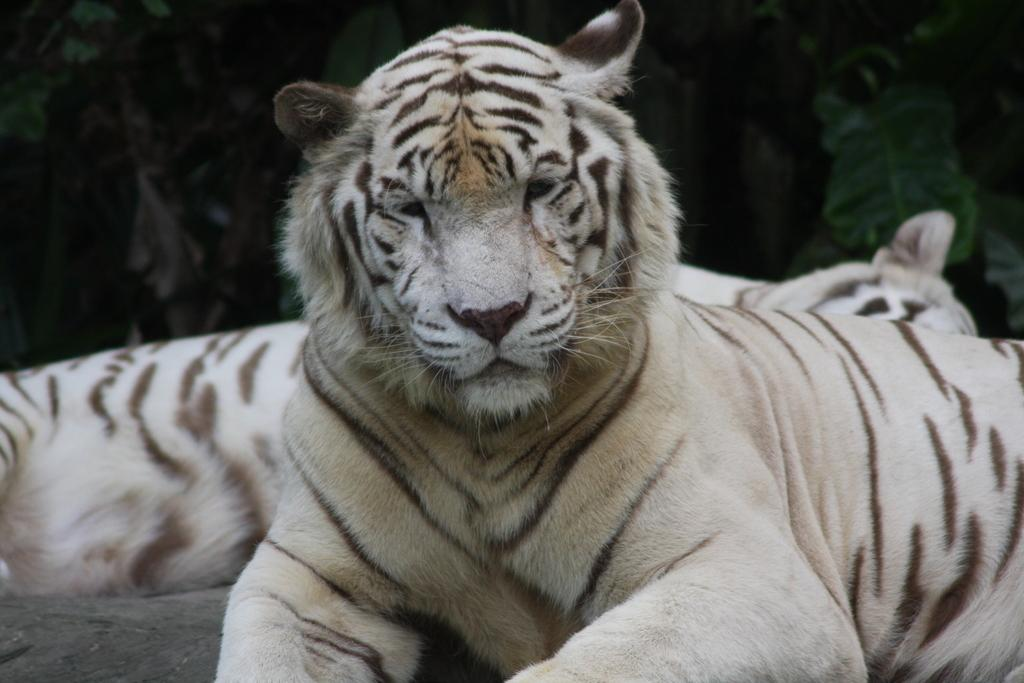What animals are in the center of the image? There are two tigers in the center of the image. What can be seen in the background of the image? There are trees in the background of the image. How many toes does the toad have in the image? There is no toad present in the image, so we cannot determine the number of toes it might have. 